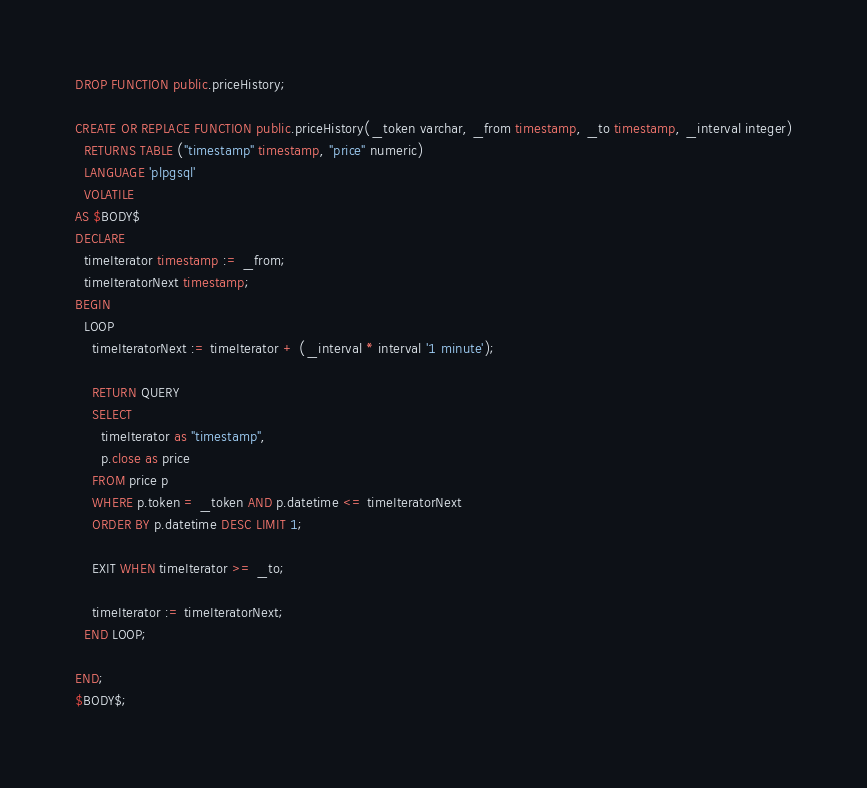<code> <loc_0><loc_0><loc_500><loc_500><_SQL_>DROP FUNCTION public.priceHistory;

CREATE OR REPLACE FUNCTION public.priceHistory(_token varchar, _from timestamp, _to timestamp, _interval integer)
  RETURNS TABLE ("timestamp" timestamp, "price" numeric)
  LANGUAGE 'plpgsql'
  VOLATILE 
AS $BODY$
DECLARE
  timeIterator timestamp := _from;
  timeIteratorNext timestamp;
BEGIN
  LOOP
    timeIteratorNext := timeIterator + (_interval * interval '1 minute');

    RETURN QUERY
    SELECT
      timeIterator as "timestamp",
      p.close as price
    FROM price p
    WHERE p.token = _token AND p.datetime <= timeIteratorNext
    ORDER BY p.datetime DESC LIMIT 1;

    EXIT WHEN timeIterator >= _to;

    timeIterator := timeIteratorNext;
  END LOOP;

END;
$BODY$;
</code> 